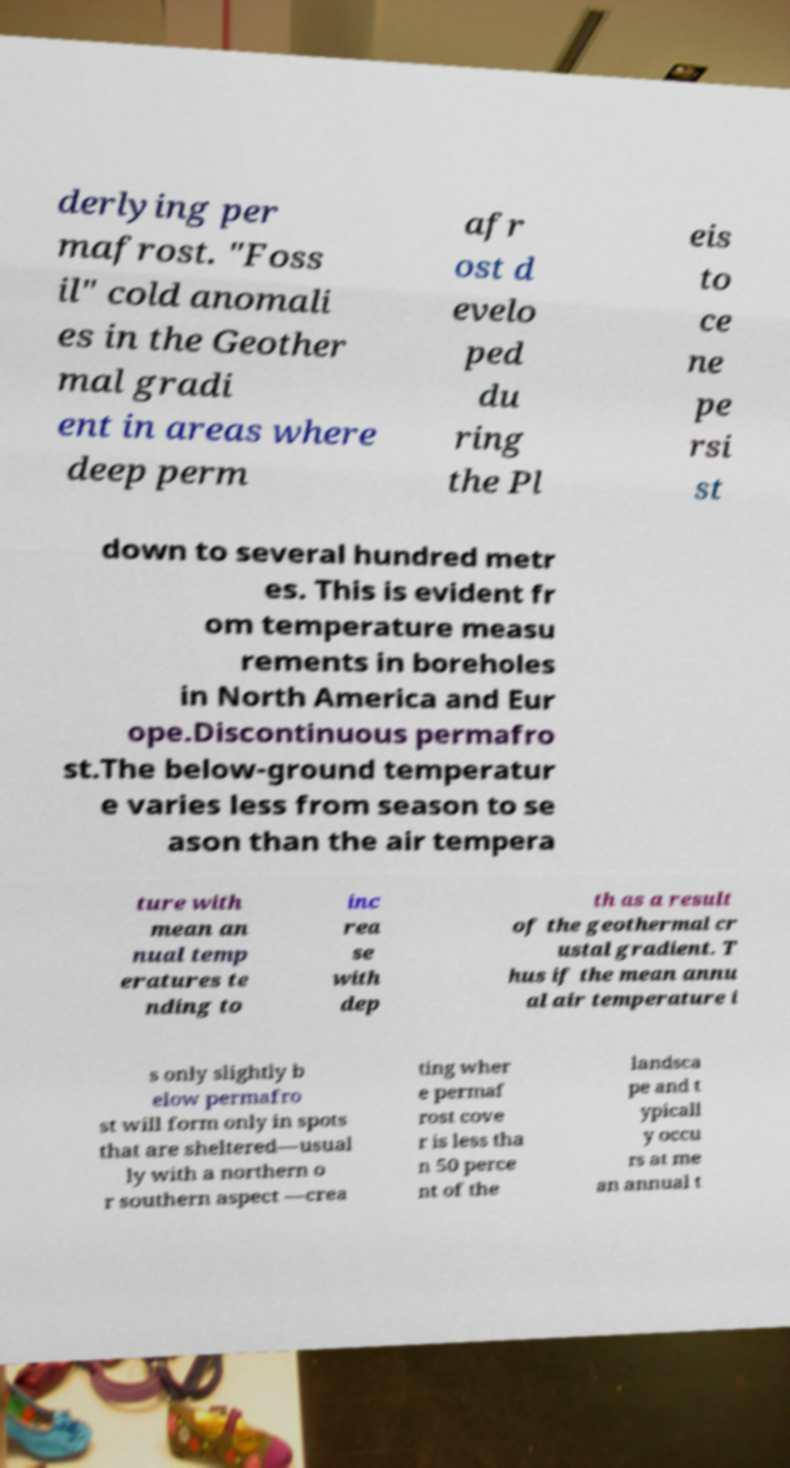What messages or text are displayed in this image? I need them in a readable, typed format. derlying per mafrost. "Foss il" cold anomali es in the Geother mal gradi ent in areas where deep perm afr ost d evelo ped du ring the Pl eis to ce ne pe rsi st down to several hundred metr es. This is evident fr om temperature measu rements in boreholes in North America and Eur ope.Discontinuous permafro st.The below-ground temperatur e varies less from season to se ason than the air tempera ture with mean an nual temp eratures te nding to inc rea se with dep th as a result of the geothermal cr ustal gradient. T hus if the mean annu al air temperature i s only slightly b elow permafro st will form only in spots that are sheltered—usual ly with a northern o r southern aspect —crea ting wher e permaf rost cove r is less tha n 50 perce nt of the landsca pe and t ypicall y occu rs at me an annual t 